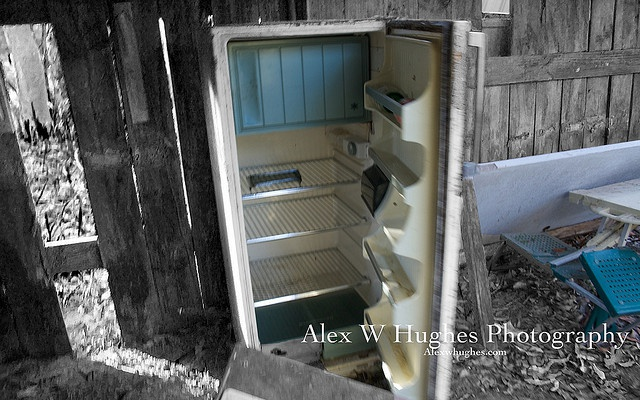Describe the objects in this image and their specific colors. I can see refrigerator in black, gray, darkgray, and lightgray tones and bench in black, gray, blue, and darkblue tones in this image. 